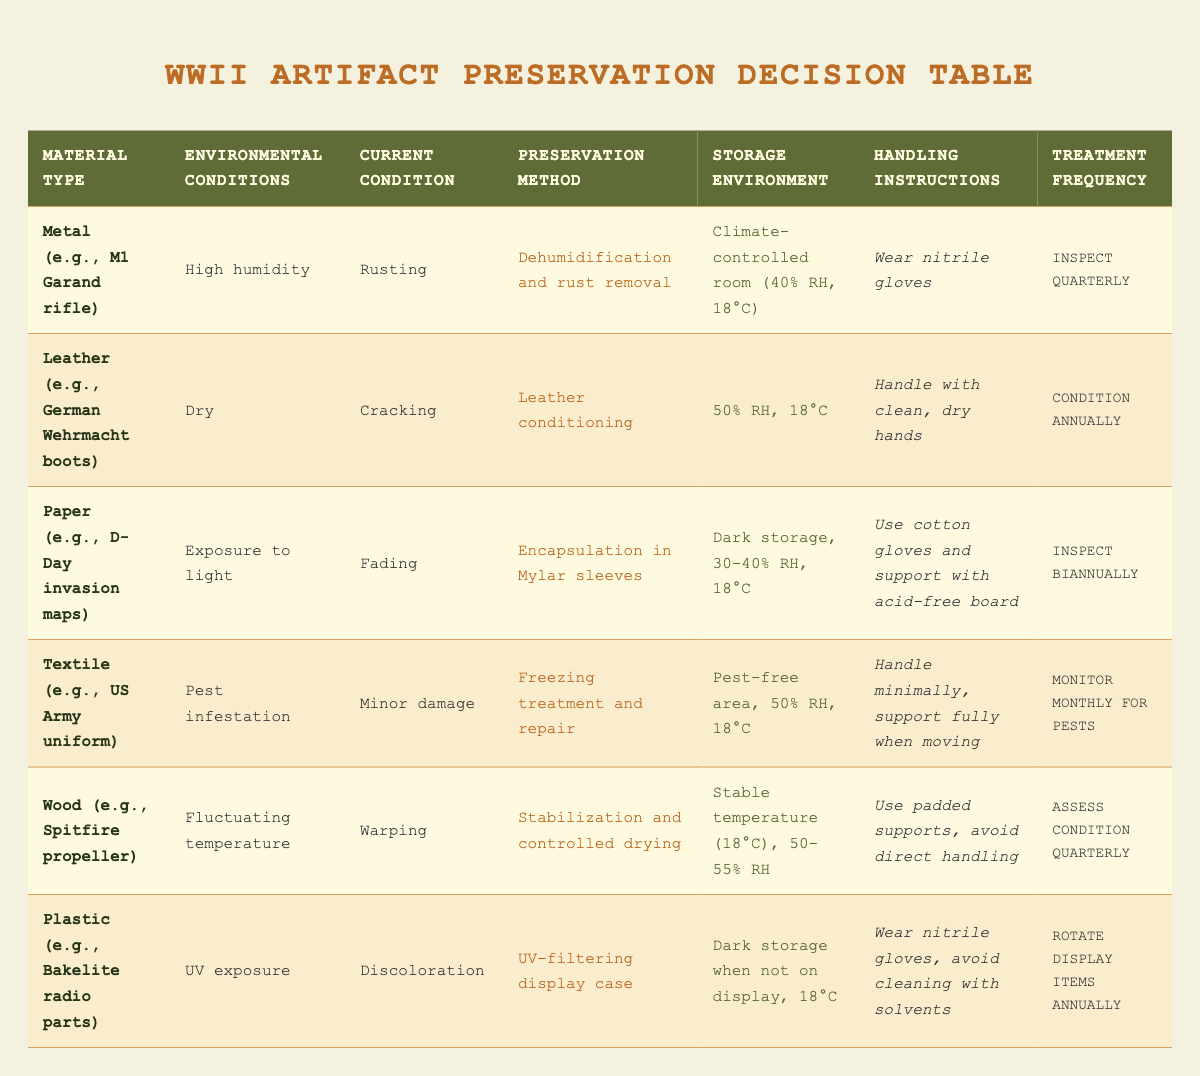What preservation method is recommended for rusting metal artifacts? The table indicates that for metal artifacts, specifically those that are rusting, the recommended preservation method is "Dehumidification and rust removal."
Answer: Dehumidification and rust removal What should the storage environment be for leather artifacts in dry conditions? According to the table, leather artifacts that are in dry conditions should be stored at "50% RH, 18°C."
Answer: 50% RH, 18°C Is encapsulation in Mylar sleeves necessary for fading paper artifacts? Yes, based on the table, fading paper artifacts require encapsulation in Mylar sleeves as their preservation method.
Answer: Yes What is the treatment frequency for textiles with minor damage in a pest-infested environment? The table states that textiles with minor damage in areas with pest infestation should be monitored monthly for pests, which is their treatment frequency.
Answer: Monitor monthly for pests What are the handling instructions for wooden artifacts that are warping? The handling instructions for warping wooden artifacts are to "Use padded supports, avoid direct handling," as specified in the table.
Answer: Use padded supports, avoid direct handling How many different current conditions are listed for artifacts in the table? The current conditions listed are rusting, cracking, fading, minor damage, warping, and discoloration, totaling six different conditions.
Answer: Six Which material type requires a UV-filtering display case? According to the table, plastic materials, such as Bakelite radio parts, require a UV-filtering display case when exposed to UV light.
Answer: Plastic What is the average relative humidity recommended for most artifacts in this table? The recommended relative humidity values from the table are 40%, 50%, and 30-40%. The average can be computed as follows: (40 + 50 + (30 + 40)/2 + 50 + 55) / 5 = 44%.
Answer: 44% Are nitrile gloves necessary for handling any of the artifacts listed? Yes, the table specifies that nitrile gloves should be worn when handling metal artifacts and plastic artifacts.
Answer: Yes 